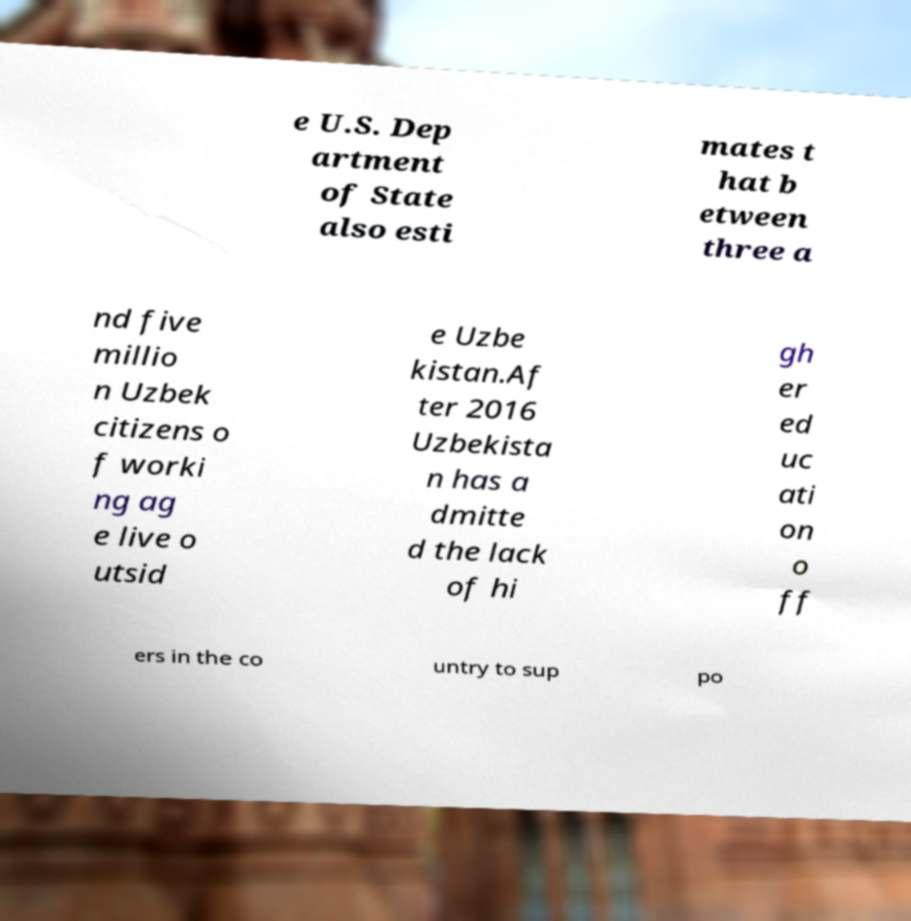For documentation purposes, I need the text within this image transcribed. Could you provide that? e U.S. Dep artment of State also esti mates t hat b etween three a nd five millio n Uzbek citizens o f worki ng ag e live o utsid e Uzbe kistan.Af ter 2016 Uzbekista n has a dmitte d the lack of hi gh er ed uc ati on o ff ers in the co untry to sup po 